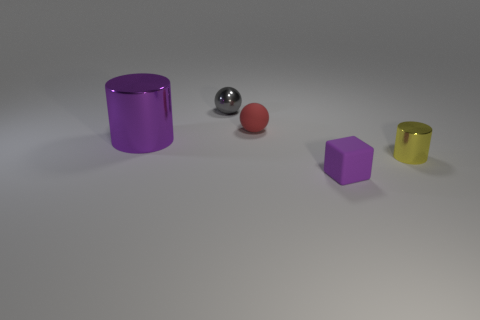Add 2 purple metal objects. How many objects exist? 7 Subtract all cylinders. How many objects are left? 3 Subtract all gray metallic spheres. Subtract all gray metallic spheres. How many objects are left? 3 Add 4 balls. How many balls are left? 6 Add 2 large things. How many large things exist? 3 Subtract 1 gray balls. How many objects are left? 4 